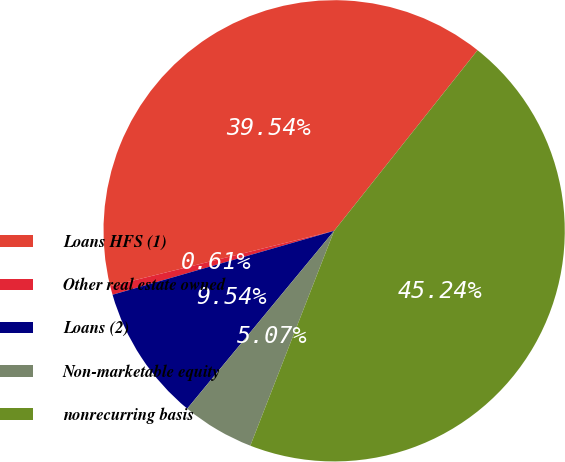<chart> <loc_0><loc_0><loc_500><loc_500><pie_chart><fcel>Loans HFS (1)<fcel>Other real estate owned<fcel>Loans (2)<fcel>Non-marketable equity<fcel>nonrecurring basis<nl><fcel>39.54%<fcel>0.61%<fcel>9.54%<fcel>5.07%<fcel>45.24%<nl></chart> 